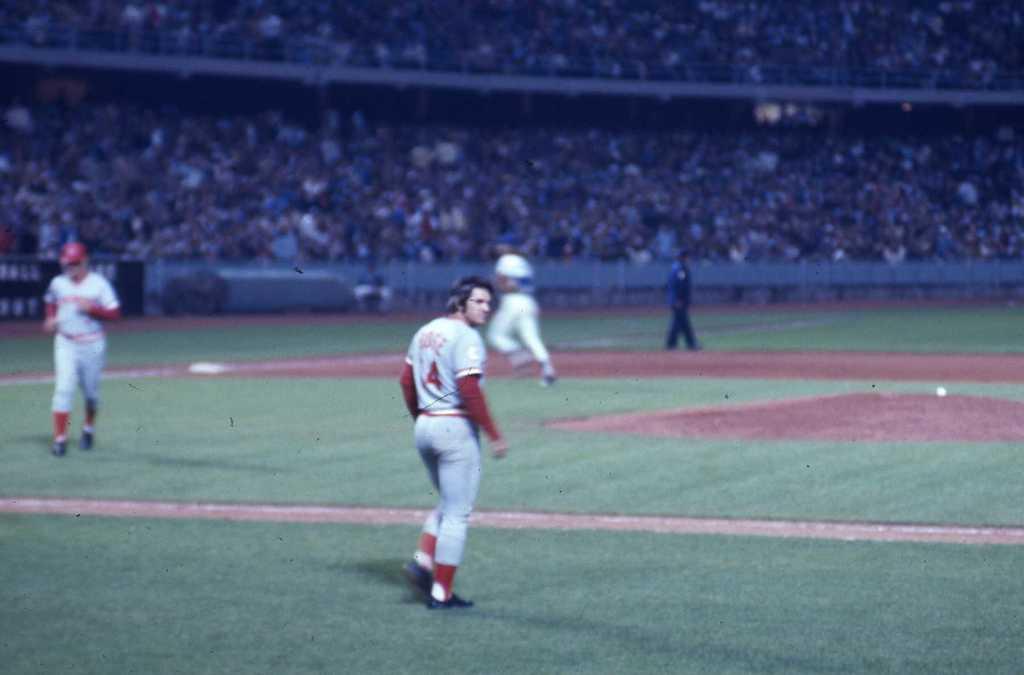What is the number on the player's jersey?
Provide a short and direct response. 4. 